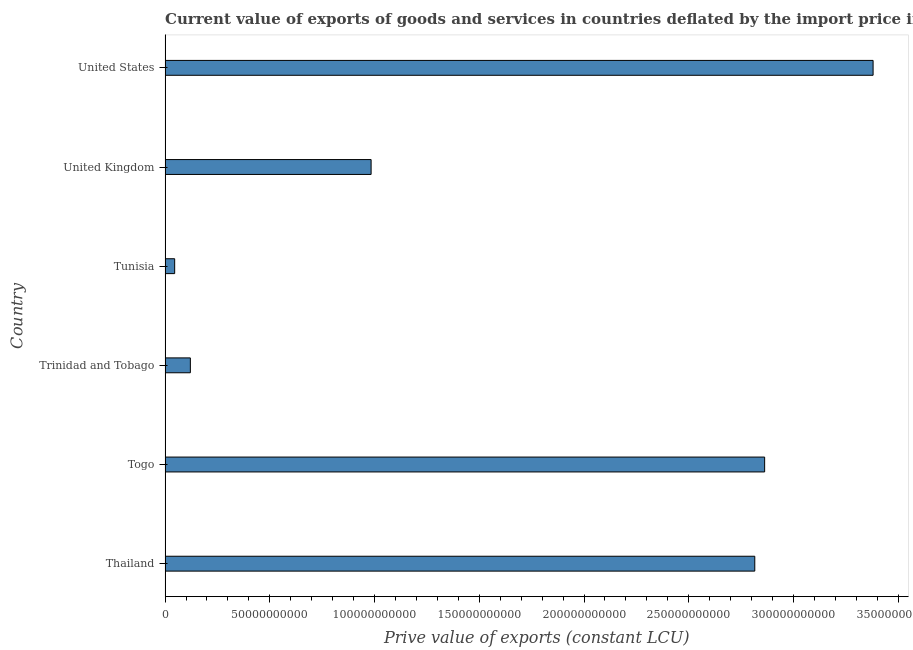Does the graph contain any zero values?
Give a very brief answer. No. What is the title of the graph?
Offer a very short reply. Current value of exports of goods and services in countries deflated by the import price index. What is the label or title of the X-axis?
Provide a succinct answer. Prive value of exports (constant LCU). What is the price value of exports in Togo?
Ensure brevity in your answer.  2.86e+11. Across all countries, what is the maximum price value of exports?
Offer a very short reply. 3.38e+11. Across all countries, what is the minimum price value of exports?
Keep it short and to the point. 4.57e+09. In which country was the price value of exports minimum?
Your response must be concise. Tunisia. What is the sum of the price value of exports?
Offer a very short reply. 1.02e+12. What is the difference between the price value of exports in Thailand and Tunisia?
Offer a very short reply. 2.77e+11. What is the average price value of exports per country?
Offer a very short reply. 1.70e+11. What is the median price value of exports?
Give a very brief answer. 1.90e+11. In how many countries, is the price value of exports greater than 90000000000 LCU?
Your answer should be very brief. 4. What is the ratio of the price value of exports in Thailand to that in Trinidad and Tobago?
Make the answer very short. 23.34. Is the price value of exports in Thailand less than that in Trinidad and Tobago?
Make the answer very short. No. What is the difference between the highest and the second highest price value of exports?
Provide a short and direct response. 5.18e+1. What is the difference between the highest and the lowest price value of exports?
Provide a short and direct response. 3.33e+11. Are all the bars in the graph horizontal?
Ensure brevity in your answer.  Yes. How many countries are there in the graph?
Make the answer very short. 6. What is the Prive value of exports (constant LCU) of Thailand?
Make the answer very short. 2.82e+11. What is the Prive value of exports (constant LCU) in Togo?
Ensure brevity in your answer.  2.86e+11. What is the Prive value of exports (constant LCU) in Trinidad and Tobago?
Make the answer very short. 1.21e+1. What is the Prive value of exports (constant LCU) of Tunisia?
Your response must be concise. 4.57e+09. What is the Prive value of exports (constant LCU) of United Kingdom?
Offer a very short reply. 9.84e+1. What is the Prive value of exports (constant LCU) in United States?
Keep it short and to the point. 3.38e+11. What is the difference between the Prive value of exports (constant LCU) in Thailand and Togo?
Your answer should be very brief. -4.71e+09. What is the difference between the Prive value of exports (constant LCU) in Thailand and Trinidad and Tobago?
Ensure brevity in your answer.  2.69e+11. What is the difference between the Prive value of exports (constant LCU) in Thailand and Tunisia?
Ensure brevity in your answer.  2.77e+11. What is the difference between the Prive value of exports (constant LCU) in Thailand and United Kingdom?
Ensure brevity in your answer.  1.83e+11. What is the difference between the Prive value of exports (constant LCU) in Thailand and United States?
Keep it short and to the point. -5.65e+1. What is the difference between the Prive value of exports (constant LCU) in Togo and Trinidad and Tobago?
Offer a terse response. 2.74e+11. What is the difference between the Prive value of exports (constant LCU) in Togo and Tunisia?
Ensure brevity in your answer.  2.82e+11. What is the difference between the Prive value of exports (constant LCU) in Togo and United Kingdom?
Keep it short and to the point. 1.88e+11. What is the difference between the Prive value of exports (constant LCU) in Togo and United States?
Keep it short and to the point. -5.18e+1. What is the difference between the Prive value of exports (constant LCU) in Trinidad and Tobago and Tunisia?
Keep it short and to the point. 7.49e+09. What is the difference between the Prive value of exports (constant LCU) in Trinidad and Tobago and United Kingdom?
Offer a terse response. -8.63e+1. What is the difference between the Prive value of exports (constant LCU) in Trinidad and Tobago and United States?
Offer a terse response. -3.26e+11. What is the difference between the Prive value of exports (constant LCU) in Tunisia and United Kingdom?
Your answer should be compact. -9.38e+1. What is the difference between the Prive value of exports (constant LCU) in Tunisia and United States?
Give a very brief answer. -3.33e+11. What is the difference between the Prive value of exports (constant LCU) in United Kingdom and United States?
Make the answer very short. -2.40e+11. What is the ratio of the Prive value of exports (constant LCU) in Thailand to that in Trinidad and Tobago?
Offer a very short reply. 23.34. What is the ratio of the Prive value of exports (constant LCU) in Thailand to that in Tunisia?
Give a very brief answer. 61.6. What is the ratio of the Prive value of exports (constant LCU) in Thailand to that in United Kingdom?
Your answer should be very brief. 2.86. What is the ratio of the Prive value of exports (constant LCU) in Thailand to that in United States?
Keep it short and to the point. 0.83. What is the ratio of the Prive value of exports (constant LCU) in Togo to that in Trinidad and Tobago?
Provide a succinct answer. 23.73. What is the ratio of the Prive value of exports (constant LCU) in Togo to that in Tunisia?
Your answer should be compact. 62.63. What is the ratio of the Prive value of exports (constant LCU) in Togo to that in United Kingdom?
Your answer should be compact. 2.91. What is the ratio of the Prive value of exports (constant LCU) in Togo to that in United States?
Your answer should be very brief. 0.85. What is the ratio of the Prive value of exports (constant LCU) in Trinidad and Tobago to that in Tunisia?
Your response must be concise. 2.64. What is the ratio of the Prive value of exports (constant LCU) in Trinidad and Tobago to that in United Kingdom?
Provide a short and direct response. 0.12. What is the ratio of the Prive value of exports (constant LCU) in Trinidad and Tobago to that in United States?
Provide a succinct answer. 0.04. What is the ratio of the Prive value of exports (constant LCU) in Tunisia to that in United Kingdom?
Ensure brevity in your answer.  0.05. What is the ratio of the Prive value of exports (constant LCU) in Tunisia to that in United States?
Your answer should be compact. 0.01. What is the ratio of the Prive value of exports (constant LCU) in United Kingdom to that in United States?
Offer a very short reply. 0.29. 